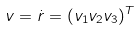Convert formula to latex. <formula><loc_0><loc_0><loc_500><loc_500>v = \dot { r } = ( v _ { 1 } v _ { 2 } v _ { 3 } ) ^ { T }</formula> 